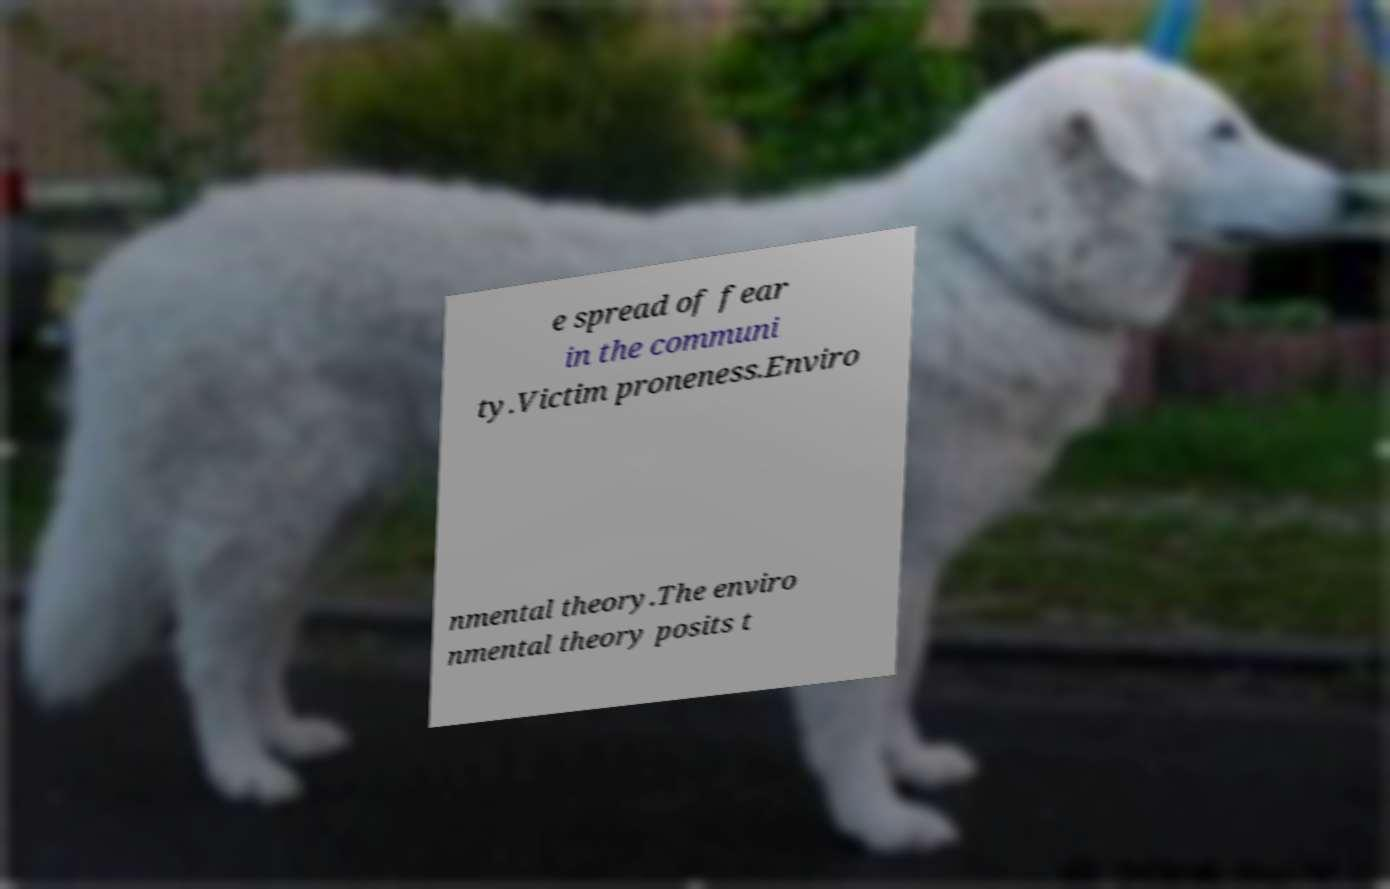Please read and relay the text visible in this image. What does it say? e spread of fear in the communi ty.Victim proneness.Enviro nmental theory.The enviro nmental theory posits t 